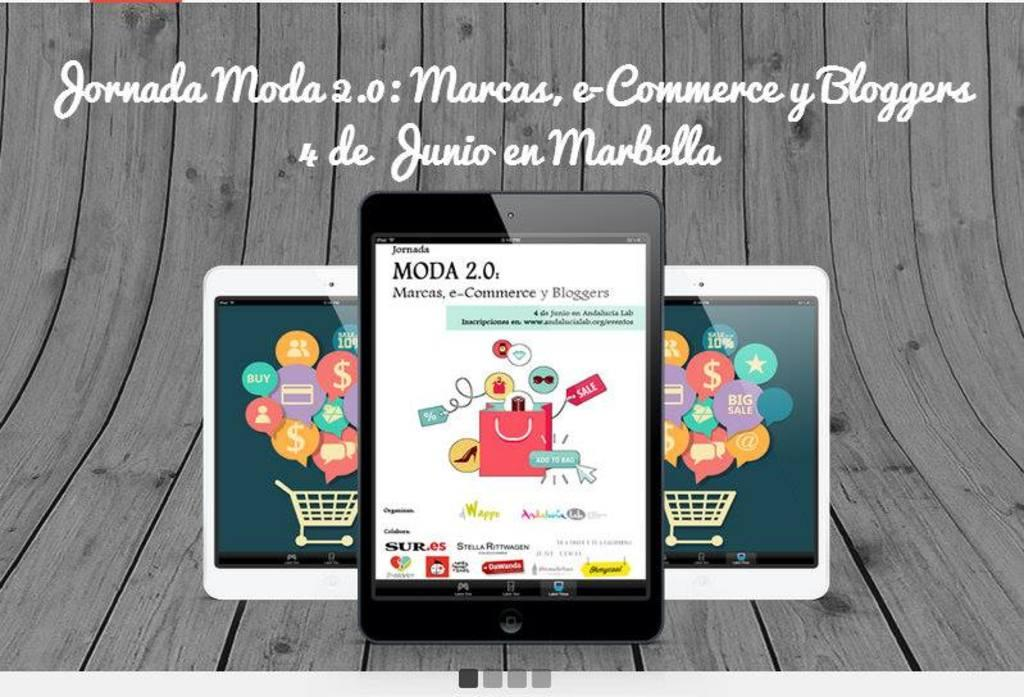Provide a one-sentence caption for the provided image. 3 tablets that have the app Moda 2.0 on them. 